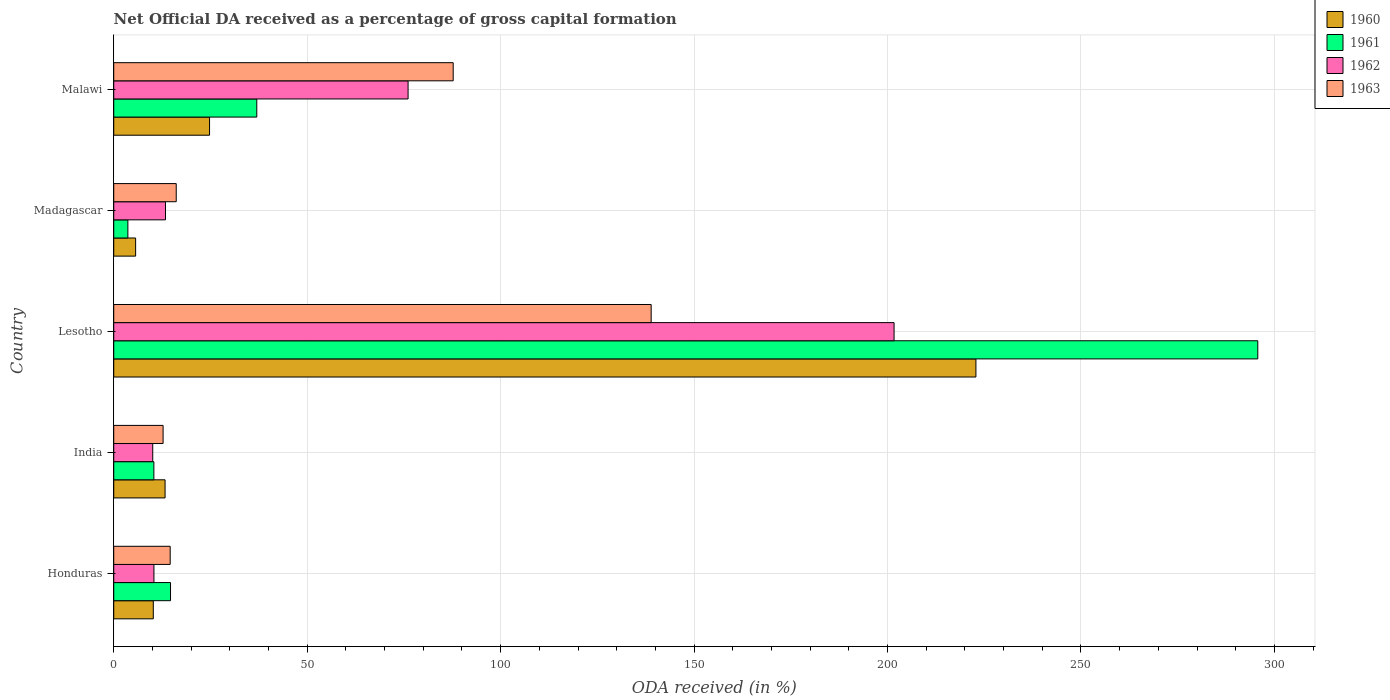How many different coloured bars are there?
Make the answer very short. 4. How many groups of bars are there?
Give a very brief answer. 5. Are the number of bars per tick equal to the number of legend labels?
Your answer should be compact. Yes. Are the number of bars on each tick of the Y-axis equal?
Offer a terse response. Yes. How many bars are there on the 4th tick from the top?
Your answer should be very brief. 4. How many bars are there on the 4th tick from the bottom?
Give a very brief answer. 4. What is the label of the 5th group of bars from the top?
Your answer should be compact. Honduras. What is the net ODA received in 1960 in Malawi?
Your answer should be very brief. 24.76. Across all countries, what is the maximum net ODA received in 1961?
Keep it short and to the point. 295.71. Across all countries, what is the minimum net ODA received in 1960?
Your response must be concise. 5.66. In which country was the net ODA received in 1960 maximum?
Your response must be concise. Lesotho. What is the total net ODA received in 1963 in the graph?
Ensure brevity in your answer.  270.16. What is the difference between the net ODA received in 1962 in Honduras and that in India?
Provide a succinct answer. 0.31. What is the difference between the net ODA received in 1962 in Lesotho and the net ODA received in 1960 in Madagascar?
Provide a short and direct response. 196.05. What is the average net ODA received in 1960 per country?
Offer a very short reply. 55.35. What is the difference between the net ODA received in 1961 and net ODA received in 1960 in India?
Offer a terse response. -2.9. In how many countries, is the net ODA received in 1960 greater than 100 %?
Ensure brevity in your answer.  1. What is the ratio of the net ODA received in 1963 in India to that in Madagascar?
Offer a very short reply. 0.79. Is the difference between the net ODA received in 1961 in India and Madagascar greater than the difference between the net ODA received in 1960 in India and Madagascar?
Keep it short and to the point. No. What is the difference between the highest and the second highest net ODA received in 1961?
Make the answer very short. 258.74. What is the difference between the highest and the lowest net ODA received in 1962?
Your answer should be compact. 191.62. Is the sum of the net ODA received in 1961 in India and Lesotho greater than the maximum net ODA received in 1963 across all countries?
Provide a succinct answer. Yes. Is it the case that in every country, the sum of the net ODA received in 1963 and net ODA received in 1960 is greater than the net ODA received in 1962?
Ensure brevity in your answer.  Yes. How many bars are there?
Offer a very short reply. 20. Are all the bars in the graph horizontal?
Your answer should be very brief. Yes. What is the difference between two consecutive major ticks on the X-axis?
Your answer should be compact. 50. What is the title of the graph?
Keep it short and to the point. Net Official DA received as a percentage of gross capital formation. Does "1998" appear as one of the legend labels in the graph?
Ensure brevity in your answer.  No. What is the label or title of the X-axis?
Make the answer very short. ODA received (in %). What is the ODA received (in %) in 1960 in Honduras?
Ensure brevity in your answer.  10.23. What is the ODA received (in %) in 1961 in Honduras?
Ensure brevity in your answer.  14.68. What is the ODA received (in %) of 1962 in Honduras?
Keep it short and to the point. 10.39. What is the ODA received (in %) of 1963 in Honduras?
Make the answer very short. 14.59. What is the ODA received (in %) of 1960 in India?
Give a very brief answer. 13.27. What is the ODA received (in %) in 1961 in India?
Your answer should be compact. 10.37. What is the ODA received (in %) of 1962 in India?
Ensure brevity in your answer.  10.08. What is the ODA received (in %) in 1963 in India?
Offer a terse response. 12.76. What is the ODA received (in %) in 1960 in Lesotho?
Offer a terse response. 222.86. What is the ODA received (in %) in 1961 in Lesotho?
Make the answer very short. 295.71. What is the ODA received (in %) in 1962 in Lesotho?
Give a very brief answer. 201.7. What is the ODA received (in %) in 1963 in Lesotho?
Keep it short and to the point. 138.92. What is the ODA received (in %) in 1960 in Madagascar?
Your response must be concise. 5.66. What is the ODA received (in %) of 1961 in Madagascar?
Your response must be concise. 3.65. What is the ODA received (in %) in 1962 in Madagascar?
Provide a succinct answer. 13.38. What is the ODA received (in %) in 1963 in Madagascar?
Your response must be concise. 16.15. What is the ODA received (in %) in 1960 in Malawi?
Your response must be concise. 24.76. What is the ODA received (in %) of 1961 in Malawi?
Keep it short and to the point. 36.97. What is the ODA received (in %) in 1962 in Malawi?
Provide a short and direct response. 76.08. What is the ODA received (in %) of 1963 in Malawi?
Your answer should be compact. 87.74. Across all countries, what is the maximum ODA received (in %) of 1960?
Offer a terse response. 222.86. Across all countries, what is the maximum ODA received (in %) in 1961?
Your response must be concise. 295.71. Across all countries, what is the maximum ODA received (in %) of 1962?
Provide a succinct answer. 201.7. Across all countries, what is the maximum ODA received (in %) of 1963?
Keep it short and to the point. 138.92. Across all countries, what is the minimum ODA received (in %) in 1960?
Your answer should be very brief. 5.66. Across all countries, what is the minimum ODA received (in %) of 1961?
Your answer should be very brief. 3.65. Across all countries, what is the minimum ODA received (in %) of 1962?
Ensure brevity in your answer.  10.08. Across all countries, what is the minimum ODA received (in %) in 1963?
Offer a very short reply. 12.76. What is the total ODA received (in %) in 1960 in the graph?
Offer a very short reply. 276.77. What is the total ODA received (in %) of 1961 in the graph?
Keep it short and to the point. 361.39. What is the total ODA received (in %) of 1962 in the graph?
Offer a very short reply. 311.63. What is the total ODA received (in %) of 1963 in the graph?
Offer a terse response. 270.16. What is the difference between the ODA received (in %) of 1960 in Honduras and that in India?
Provide a succinct answer. -3.05. What is the difference between the ODA received (in %) of 1961 in Honduras and that in India?
Provide a succinct answer. 4.3. What is the difference between the ODA received (in %) in 1962 in Honduras and that in India?
Offer a very short reply. 0.31. What is the difference between the ODA received (in %) in 1963 in Honduras and that in India?
Give a very brief answer. 1.84. What is the difference between the ODA received (in %) in 1960 in Honduras and that in Lesotho?
Your answer should be very brief. -212.63. What is the difference between the ODA received (in %) of 1961 in Honduras and that in Lesotho?
Provide a short and direct response. -281.04. What is the difference between the ODA received (in %) in 1962 in Honduras and that in Lesotho?
Your answer should be compact. -191.31. What is the difference between the ODA received (in %) of 1963 in Honduras and that in Lesotho?
Give a very brief answer. -124.33. What is the difference between the ODA received (in %) of 1960 in Honduras and that in Madagascar?
Make the answer very short. 4.57. What is the difference between the ODA received (in %) of 1961 in Honduras and that in Madagascar?
Your answer should be compact. 11.03. What is the difference between the ODA received (in %) in 1962 in Honduras and that in Madagascar?
Provide a succinct answer. -2.99. What is the difference between the ODA received (in %) of 1963 in Honduras and that in Madagascar?
Offer a very short reply. -1.56. What is the difference between the ODA received (in %) in 1960 in Honduras and that in Malawi?
Keep it short and to the point. -14.54. What is the difference between the ODA received (in %) in 1961 in Honduras and that in Malawi?
Make the answer very short. -22.29. What is the difference between the ODA received (in %) of 1962 in Honduras and that in Malawi?
Offer a terse response. -65.69. What is the difference between the ODA received (in %) in 1963 in Honduras and that in Malawi?
Ensure brevity in your answer.  -73.15. What is the difference between the ODA received (in %) of 1960 in India and that in Lesotho?
Provide a short and direct response. -209.59. What is the difference between the ODA received (in %) in 1961 in India and that in Lesotho?
Make the answer very short. -285.34. What is the difference between the ODA received (in %) in 1962 in India and that in Lesotho?
Give a very brief answer. -191.62. What is the difference between the ODA received (in %) of 1963 in India and that in Lesotho?
Ensure brevity in your answer.  -126.16. What is the difference between the ODA received (in %) of 1960 in India and that in Madagascar?
Keep it short and to the point. 7.62. What is the difference between the ODA received (in %) in 1961 in India and that in Madagascar?
Offer a terse response. 6.72. What is the difference between the ODA received (in %) of 1962 in India and that in Madagascar?
Offer a very short reply. -3.3. What is the difference between the ODA received (in %) of 1963 in India and that in Madagascar?
Give a very brief answer. -3.4. What is the difference between the ODA received (in %) of 1960 in India and that in Malawi?
Provide a short and direct response. -11.49. What is the difference between the ODA received (in %) in 1961 in India and that in Malawi?
Offer a terse response. -26.6. What is the difference between the ODA received (in %) in 1962 in India and that in Malawi?
Your answer should be very brief. -66. What is the difference between the ODA received (in %) in 1963 in India and that in Malawi?
Provide a succinct answer. -74.98. What is the difference between the ODA received (in %) of 1960 in Lesotho and that in Madagascar?
Ensure brevity in your answer.  217.2. What is the difference between the ODA received (in %) of 1961 in Lesotho and that in Madagascar?
Your response must be concise. 292.06. What is the difference between the ODA received (in %) in 1962 in Lesotho and that in Madagascar?
Ensure brevity in your answer.  188.32. What is the difference between the ODA received (in %) in 1963 in Lesotho and that in Madagascar?
Keep it short and to the point. 122.76. What is the difference between the ODA received (in %) in 1960 in Lesotho and that in Malawi?
Keep it short and to the point. 198.1. What is the difference between the ODA received (in %) of 1961 in Lesotho and that in Malawi?
Give a very brief answer. 258.74. What is the difference between the ODA received (in %) of 1962 in Lesotho and that in Malawi?
Give a very brief answer. 125.62. What is the difference between the ODA received (in %) in 1963 in Lesotho and that in Malawi?
Ensure brevity in your answer.  51.18. What is the difference between the ODA received (in %) in 1960 in Madagascar and that in Malawi?
Offer a very short reply. -19.11. What is the difference between the ODA received (in %) in 1961 in Madagascar and that in Malawi?
Offer a terse response. -33.32. What is the difference between the ODA received (in %) in 1962 in Madagascar and that in Malawi?
Make the answer very short. -62.7. What is the difference between the ODA received (in %) in 1963 in Madagascar and that in Malawi?
Make the answer very short. -71.59. What is the difference between the ODA received (in %) in 1960 in Honduras and the ODA received (in %) in 1961 in India?
Offer a very short reply. -0.15. What is the difference between the ODA received (in %) of 1960 in Honduras and the ODA received (in %) of 1962 in India?
Provide a short and direct response. 0.14. What is the difference between the ODA received (in %) in 1960 in Honduras and the ODA received (in %) in 1963 in India?
Offer a terse response. -2.53. What is the difference between the ODA received (in %) in 1961 in Honduras and the ODA received (in %) in 1962 in India?
Your answer should be very brief. 4.6. What is the difference between the ODA received (in %) of 1961 in Honduras and the ODA received (in %) of 1963 in India?
Your answer should be compact. 1.92. What is the difference between the ODA received (in %) of 1962 in Honduras and the ODA received (in %) of 1963 in India?
Offer a terse response. -2.37. What is the difference between the ODA received (in %) of 1960 in Honduras and the ODA received (in %) of 1961 in Lesotho?
Offer a terse response. -285.49. What is the difference between the ODA received (in %) in 1960 in Honduras and the ODA received (in %) in 1962 in Lesotho?
Offer a very short reply. -191.48. What is the difference between the ODA received (in %) in 1960 in Honduras and the ODA received (in %) in 1963 in Lesotho?
Your answer should be compact. -128.69. What is the difference between the ODA received (in %) in 1961 in Honduras and the ODA received (in %) in 1962 in Lesotho?
Your response must be concise. -187.02. What is the difference between the ODA received (in %) of 1961 in Honduras and the ODA received (in %) of 1963 in Lesotho?
Offer a terse response. -124.24. What is the difference between the ODA received (in %) of 1962 in Honduras and the ODA received (in %) of 1963 in Lesotho?
Your answer should be compact. -128.53. What is the difference between the ODA received (in %) of 1960 in Honduras and the ODA received (in %) of 1961 in Madagascar?
Give a very brief answer. 6.57. What is the difference between the ODA received (in %) of 1960 in Honduras and the ODA received (in %) of 1962 in Madagascar?
Ensure brevity in your answer.  -3.16. What is the difference between the ODA received (in %) of 1960 in Honduras and the ODA received (in %) of 1963 in Madagascar?
Provide a succinct answer. -5.93. What is the difference between the ODA received (in %) in 1961 in Honduras and the ODA received (in %) in 1962 in Madagascar?
Ensure brevity in your answer.  1.3. What is the difference between the ODA received (in %) in 1961 in Honduras and the ODA received (in %) in 1963 in Madagascar?
Your answer should be compact. -1.48. What is the difference between the ODA received (in %) in 1962 in Honduras and the ODA received (in %) in 1963 in Madagascar?
Ensure brevity in your answer.  -5.76. What is the difference between the ODA received (in %) of 1960 in Honduras and the ODA received (in %) of 1961 in Malawi?
Offer a very short reply. -26.75. What is the difference between the ODA received (in %) in 1960 in Honduras and the ODA received (in %) in 1962 in Malawi?
Provide a succinct answer. -65.86. What is the difference between the ODA received (in %) of 1960 in Honduras and the ODA received (in %) of 1963 in Malawi?
Offer a terse response. -77.51. What is the difference between the ODA received (in %) of 1961 in Honduras and the ODA received (in %) of 1962 in Malawi?
Give a very brief answer. -61.4. What is the difference between the ODA received (in %) of 1961 in Honduras and the ODA received (in %) of 1963 in Malawi?
Your response must be concise. -73.06. What is the difference between the ODA received (in %) of 1962 in Honduras and the ODA received (in %) of 1963 in Malawi?
Keep it short and to the point. -77.35. What is the difference between the ODA received (in %) in 1960 in India and the ODA received (in %) in 1961 in Lesotho?
Ensure brevity in your answer.  -282.44. What is the difference between the ODA received (in %) in 1960 in India and the ODA received (in %) in 1962 in Lesotho?
Provide a succinct answer. -188.43. What is the difference between the ODA received (in %) of 1960 in India and the ODA received (in %) of 1963 in Lesotho?
Make the answer very short. -125.65. What is the difference between the ODA received (in %) of 1961 in India and the ODA received (in %) of 1962 in Lesotho?
Provide a short and direct response. -191.33. What is the difference between the ODA received (in %) of 1961 in India and the ODA received (in %) of 1963 in Lesotho?
Your answer should be compact. -128.54. What is the difference between the ODA received (in %) in 1962 in India and the ODA received (in %) in 1963 in Lesotho?
Your answer should be very brief. -128.84. What is the difference between the ODA received (in %) of 1960 in India and the ODA received (in %) of 1961 in Madagascar?
Your answer should be very brief. 9.62. What is the difference between the ODA received (in %) of 1960 in India and the ODA received (in %) of 1962 in Madagascar?
Give a very brief answer. -0.11. What is the difference between the ODA received (in %) of 1960 in India and the ODA received (in %) of 1963 in Madagascar?
Your answer should be very brief. -2.88. What is the difference between the ODA received (in %) in 1961 in India and the ODA received (in %) in 1962 in Madagascar?
Provide a short and direct response. -3.01. What is the difference between the ODA received (in %) in 1961 in India and the ODA received (in %) in 1963 in Madagascar?
Keep it short and to the point. -5.78. What is the difference between the ODA received (in %) of 1962 in India and the ODA received (in %) of 1963 in Madagascar?
Ensure brevity in your answer.  -6.07. What is the difference between the ODA received (in %) in 1960 in India and the ODA received (in %) in 1961 in Malawi?
Make the answer very short. -23.7. What is the difference between the ODA received (in %) of 1960 in India and the ODA received (in %) of 1962 in Malawi?
Your answer should be very brief. -62.81. What is the difference between the ODA received (in %) in 1960 in India and the ODA received (in %) in 1963 in Malawi?
Offer a very short reply. -74.47. What is the difference between the ODA received (in %) of 1961 in India and the ODA received (in %) of 1962 in Malawi?
Your response must be concise. -65.71. What is the difference between the ODA received (in %) of 1961 in India and the ODA received (in %) of 1963 in Malawi?
Ensure brevity in your answer.  -77.37. What is the difference between the ODA received (in %) of 1962 in India and the ODA received (in %) of 1963 in Malawi?
Give a very brief answer. -77.66. What is the difference between the ODA received (in %) of 1960 in Lesotho and the ODA received (in %) of 1961 in Madagascar?
Provide a succinct answer. 219.21. What is the difference between the ODA received (in %) of 1960 in Lesotho and the ODA received (in %) of 1962 in Madagascar?
Your answer should be compact. 209.48. What is the difference between the ODA received (in %) of 1960 in Lesotho and the ODA received (in %) of 1963 in Madagascar?
Keep it short and to the point. 206.7. What is the difference between the ODA received (in %) of 1961 in Lesotho and the ODA received (in %) of 1962 in Madagascar?
Offer a terse response. 282.33. What is the difference between the ODA received (in %) of 1961 in Lesotho and the ODA received (in %) of 1963 in Madagascar?
Your answer should be very brief. 279.56. What is the difference between the ODA received (in %) of 1962 in Lesotho and the ODA received (in %) of 1963 in Madagascar?
Provide a short and direct response. 185.55. What is the difference between the ODA received (in %) of 1960 in Lesotho and the ODA received (in %) of 1961 in Malawi?
Provide a succinct answer. 185.89. What is the difference between the ODA received (in %) of 1960 in Lesotho and the ODA received (in %) of 1962 in Malawi?
Offer a very short reply. 146.78. What is the difference between the ODA received (in %) of 1960 in Lesotho and the ODA received (in %) of 1963 in Malawi?
Provide a short and direct response. 135.12. What is the difference between the ODA received (in %) in 1961 in Lesotho and the ODA received (in %) in 1962 in Malawi?
Give a very brief answer. 219.63. What is the difference between the ODA received (in %) in 1961 in Lesotho and the ODA received (in %) in 1963 in Malawi?
Your answer should be very brief. 207.97. What is the difference between the ODA received (in %) of 1962 in Lesotho and the ODA received (in %) of 1963 in Malawi?
Provide a succinct answer. 113.96. What is the difference between the ODA received (in %) of 1960 in Madagascar and the ODA received (in %) of 1961 in Malawi?
Your answer should be compact. -31.32. What is the difference between the ODA received (in %) in 1960 in Madagascar and the ODA received (in %) in 1962 in Malawi?
Offer a terse response. -70.43. What is the difference between the ODA received (in %) of 1960 in Madagascar and the ODA received (in %) of 1963 in Malawi?
Provide a succinct answer. -82.08. What is the difference between the ODA received (in %) in 1961 in Madagascar and the ODA received (in %) in 1962 in Malawi?
Offer a terse response. -72.43. What is the difference between the ODA received (in %) of 1961 in Madagascar and the ODA received (in %) of 1963 in Malawi?
Your answer should be very brief. -84.09. What is the difference between the ODA received (in %) in 1962 in Madagascar and the ODA received (in %) in 1963 in Malawi?
Make the answer very short. -74.36. What is the average ODA received (in %) of 1960 per country?
Your answer should be compact. 55.35. What is the average ODA received (in %) in 1961 per country?
Provide a short and direct response. 72.28. What is the average ODA received (in %) of 1962 per country?
Make the answer very short. 62.33. What is the average ODA received (in %) of 1963 per country?
Make the answer very short. 54.03. What is the difference between the ODA received (in %) in 1960 and ODA received (in %) in 1961 in Honduras?
Ensure brevity in your answer.  -4.45. What is the difference between the ODA received (in %) of 1960 and ODA received (in %) of 1962 in Honduras?
Make the answer very short. -0.16. What is the difference between the ODA received (in %) of 1960 and ODA received (in %) of 1963 in Honduras?
Offer a terse response. -4.37. What is the difference between the ODA received (in %) in 1961 and ODA received (in %) in 1962 in Honduras?
Keep it short and to the point. 4.29. What is the difference between the ODA received (in %) in 1961 and ODA received (in %) in 1963 in Honduras?
Offer a terse response. 0.09. What is the difference between the ODA received (in %) of 1962 and ODA received (in %) of 1963 in Honduras?
Offer a terse response. -4.2. What is the difference between the ODA received (in %) of 1960 and ODA received (in %) of 1961 in India?
Offer a terse response. 2.9. What is the difference between the ODA received (in %) of 1960 and ODA received (in %) of 1962 in India?
Provide a short and direct response. 3.19. What is the difference between the ODA received (in %) of 1960 and ODA received (in %) of 1963 in India?
Provide a succinct answer. 0.52. What is the difference between the ODA received (in %) of 1961 and ODA received (in %) of 1962 in India?
Offer a very short reply. 0.29. What is the difference between the ODA received (in %) of 1961 and ODA received (in %) of 1963 in India?
Provide a succinct answer. -2.38. What is the difference between the ODA received (in %) of 1962 and ODA received (in %) of 1963 in India?
Offer a very short reply. -2.68. What is the difference between the ODA received (in %) in 1960 and ODA received (in %) in 1961 in Lesotho?
Your response must be concise. -72.86. What is the difference between the ODA received (in %) in 1960 and ODA received (in %) in 1962 in Lesotho?
Ensure brevity in your answer.  21.16. What is the difference between the ODA received (in %) in 1960 and ODA received (in %) in 1963 in Lesotho?
Provide a succinct answer. 83.94. What is the difference between the ODA received (in %) of 1961 and ODA received (in %) of 1962 in Lesotho?
Make the answer very short. 94.01. What is the difference between the ODA received (in %) of 1961 and ODA received (in %) of 1963 in Lesotho?
Offer a terse response. 156.8. What is the difference between the ODA received (in %) in 1962 and ODA received (in %) in 1963 in Lesotho?
Your response must be concise. 62.78. What is the difference between the ODA received (in %) in 1960 and ODA received (in %) in 1961 in Madagascar?
Ensure brevity in your answer.  2. What is the difference between the ODA received (in %) in 1960 and ODA received (in %) in 1962 in Madagascar?
Your answer should be very brief. -7.72. What is the difference between the ODA received (in %) in 1960 and ODA received (in %) in 1963 in Madagascar?
Ensure brevity in your answer.  -10.5. What is the difference between the ODA received (in %) in 1961 and ODA received (in %) in 1962 in Madagascar?
Provide a short and direct response. -9.73. What is the difference between the ODA received (in %) in 1961 and ODA received (in %) in 1963 in Madagascar?
Provide a succinct answer. -12.5. What is the difference between the ODA received (in %) of 1962 and ODA received (in %) of 1963 in Madagascar?
Keep it short and to the point. -2.77. What is the difference between the ODA received (in %) of 1960 and ODA received (in %) of 1961 in Malawi?
Offer a terse response. -12.21. What is the difference between the ODA received (in %) in 1960 and ODA received (in %) in 1962 in Malawi?
Your answer should be compact. -51.32. What is the difference between the ODA received (in %) of 1960 and ODA received (in %) of 1963 in Malawi?
Give a very brief answer. -62.98. What is the difference between the ODA received (in %) in 1961 and ODA received (in %) in 1962 in Malawi?
Keep it short and to the point. -39.11. What is the difference between the ODA received (in %) in 1961 and ODA received (in %) in 1963 in Malawi?
Your answer should be compact. -50.77. What is the difference between the ODA received (in %) of 1962 and ODA received (in %) of 1963 in Malawi?
Provide a succinct answer. -11.66. What is the ratio of the ODA received (in %) in 1960 in Honduras to that in India?
Give a very brief answer. 0.77. What is the ratio of the ODA received (in %) in 1961 in Honduras to that in India?
Keep it short and to the point. 1.41. What is the ratio of the ODA received (in %) in 1962 in Honduras to that in India?
Your response must be concise. 1.03. What is the ratio of the ODA received (in %) of 1963 in Honduras to that in India?
Keep it short and to the point. 1.14. What is the ratio of the ODA received (in %) of 1960 in Honduras to that in Lesotho?
Offer a very short reply. 0.05. What is the ratio of the ODA received (in %) in 1961 in Honduras to that in Lesotho?
Provide a short and direct response. 0.05. What is the ratio of the ODA received (in %) in 1962 in Honduras to that in Lesotho?
Your response must be concise. 0.05. What is the ratio of the ODA received (in %) in 1963 in Honduras to that in Lesotho?
Provide a succinct answer. 0.1. What is the ratio of the ODA received (in %) in 1960 in Honduras to that in Madagascar?
Ensure brevity in your answer.  1.81. What is the ratio of the ODA received (in %) in 1961 in Honduras to that in Madagascar?
Make the answer very short. 4.02. What is the ratio of the ODA received (in %) of 1962 in Honduras to that in Madagascar?
Give a very brief answer. 0.78. What is the ratio of the ODA received (in %) in 1963 in Honduras to that in Madagascar?
Give a very brief answer. 0.9. What is the ratio of the ODA received (in %) in 1960 in Honduras to that in Malawi?
Ensure brevity in your answer.  0.41. What is the ratio of the ODA received (in %) of 1961 in Honduras to that in Malawi?
Your answer should be very brief. 0.4. What is the ratio of the ODA received (in %) of 1962 in Honduras to that in Malawi?
Provide a short and direct response. 0.14. What is the ratio of the ODA received (in %) of 1963 in Honduras to that in Malawi?
Keep it short and to the point. 0.17. What is the ratio of the ODA received (in %) in 1960 in India to that in Lesotho?
Offer a very short reply. 0.06. What is the ratio of the ODA received (in %) in 1961 in India to that in Lesotho?
Give a very brief answer. 0.04. What is the ratio of the ODA received (in %) of 1963 in India to that in Lesotho?
Ensure brevity in your answer.  0.09. What is the ratio of the ODA received (in %) of 1960 in India to that in Madagascar?
Give a very brief answer. 2.35. What is the ratio of the ODA received (in %) of 1961 in India to that in Madagascar?
Your answer should be very brief. 2.84. What is the ratio of the ODA received (in %) of 1962 in India to that in Madagascar?
Your answer should be very brief. 0.75. What is the ratio of the ODA received (in %) of 1963 in India to that in Madagascar?
Offer a terse response. 0.79. What is the ratio of the ODA received (in %) in 1960 in India to that in Malawi?
Keep it short and to the point. 0.54. What is the ratio of the ODA received (in %) of 1961 in India to that in Malawi?
Offer a terse response. 0.28. What is the ratio of the ODA received (in %) in 1962 in India to that in Malawi?
Give a very brief answer. 0.13. What is the ratio of the ODA received (in %) in 1963 in India to that in Malawi?
Keep it short and to the point. 0.15. What is the ratio of the ODA received (in %) of 1960 in Lesotho to that in Madagascar?
Your answer should be very brief. 39.4. What is the ratio of the ODA received (in %) in 1961 in Lesotho to that in Madagascar?
Offer a very short reply. 80.97. What is the ratio of the ODA received (in %) in 1962 in Lesotho to that in Madagascar?
Offer a terse response. 15.07. What is the ratio of the ODA received (in %) in 1963 in Lesotho to that in Madagascar?
Keep it short and to the point. 8.6. What is the ratio of the ODA received (in %) in 1960 in Lesotho to that in Malawi?
Your answer should be compact. 9. What is the ratio of the ODA received (in %) of 1961 in Lesotho to that in Malawi?
Keep it short and to the point. 8. What is the ratio of the ODA received (in %) of 1962 in Lesotho to that in Malawi?
Make the answer very short. 2.65. What is the ratio of the ODA received (in %) of 1963 in Lesotho to that in Malawi?
Your response must be concise. 1.58. What is the ratio of the ODA received (in %) of 1960 in Madagascar to that in Malawi?
Ensure brevity in your answer.  0.23. What is the ratio of the ODA received (in %) in 1961 in Madagascar to that in Malawi?
Give a very brief answer. 0.1. What is the ratio of the ODA received (in %) of 1962 in Madagascar to that in Malawi?
Provide a succinct answer. 0.18. What is the ratio of the ODA received (in %) of 1963 in Madagascar to that in Malawi?
Ensure brevity in your answer.  0.18. What is the difference between the highest and the second highest ODA received (in %) of 1960?
Your answer should be compact. 198.1. What is the difference between the highest and the second highest ODA received (in %) in 1961?
Give a very brief answer. 258.74. What is the difference between the highest and the second highest ODA received (in %) of 1962?
Your response must be concise. 125.62. What is the difference between the highest and the second highest ODA received (in %) of 1963?
Provide a short and direct response. 51.18. What is the difference between the highest and the lowest ODA received (in %) in 1960?
Provide a short and direct response. 217.2. What is the difference between the highest and the lowest ODA received (in %) of 1961?
Provide a succinct answer. 292.06. What is the difference between the highest and the lowest ODA received (in %) in 1962?
Offer a terse response. 191.62. What is the difference between the highest and the lowest ODA received (in %) of 1963?
Provide a short and direct response. 126.16. 